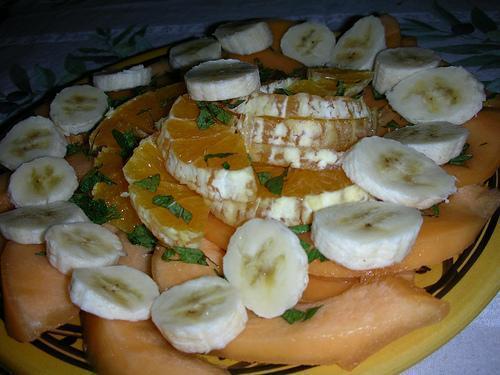How many bananas are visible?
Give a very brief answer. 13. How many oranges are in the photo?
Give a very brief answer. 2. How many people are on the elephant on the right?
Give a very brief answer. 0. 